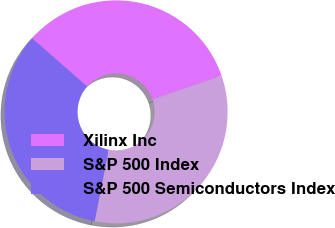<chart> <loc_0><loc_0><loc_500><loc_500><pie_chart><fcel>Xilinx Inc<fcel>S&P 500 Index<fcel>S&P 500 Semiconductors Index<nl><fcel>33.3%<fcel>33.33%<fcel>33.37%<nl></chart> 